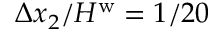<formula> <loc_0><loc_0><loc_500><loc_500>\Delta x _ { 2 } / H ^ { w } = 1 / 2 0</formula> 